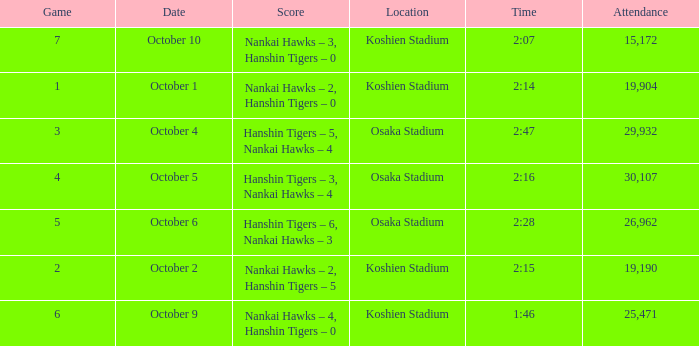Which Score has a Time of 2:28? Hanshin Tigers – 6, Nankai Hawks – 3. 